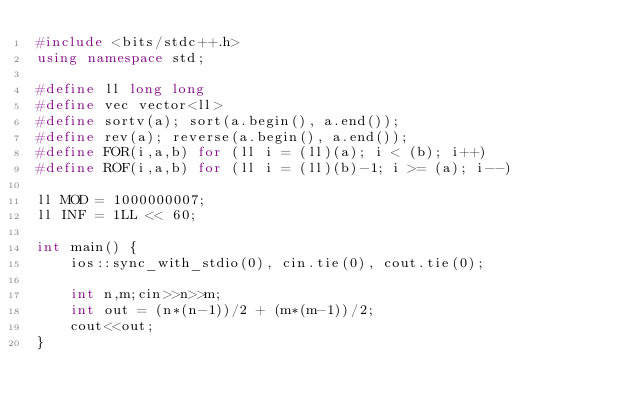Convert code to text. <code><loc_0><loc_0><loc_500><loc_500><_C++_>#include <bits/stdc++.h>
using namespace std;

#define ll long long
#define vec vector<ll>
#define sortv(a); sort(a.begin(), a.end());
#define rev(a); reverse(a.begin(), a.end());
#define FOR(i,a,b) for (ll i = (ll)(a); i < (b); i++)
#define ROF(i,a,b) for (ll i = (ll)(b)-1; i >= (a); i--)

ll MOD = 1000000007;
ll INF = 1LL << 60;

int main() {
	ios::sync_with_stdio(0), cin.tie(0), cout.tie(0);
	
	int n,m;cin>>n>>m;
	int out = (n*(n-1))/2 + (m*(m-1))/2;
	cout<<out;
}</code> 